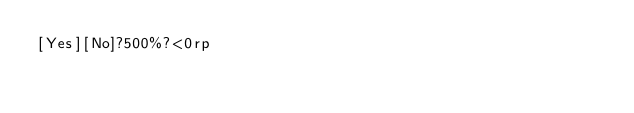<code> <loc_0><loc_0><loc_500><loc_500><_dc_>[Yes][No]?500%?<0rp</code> 